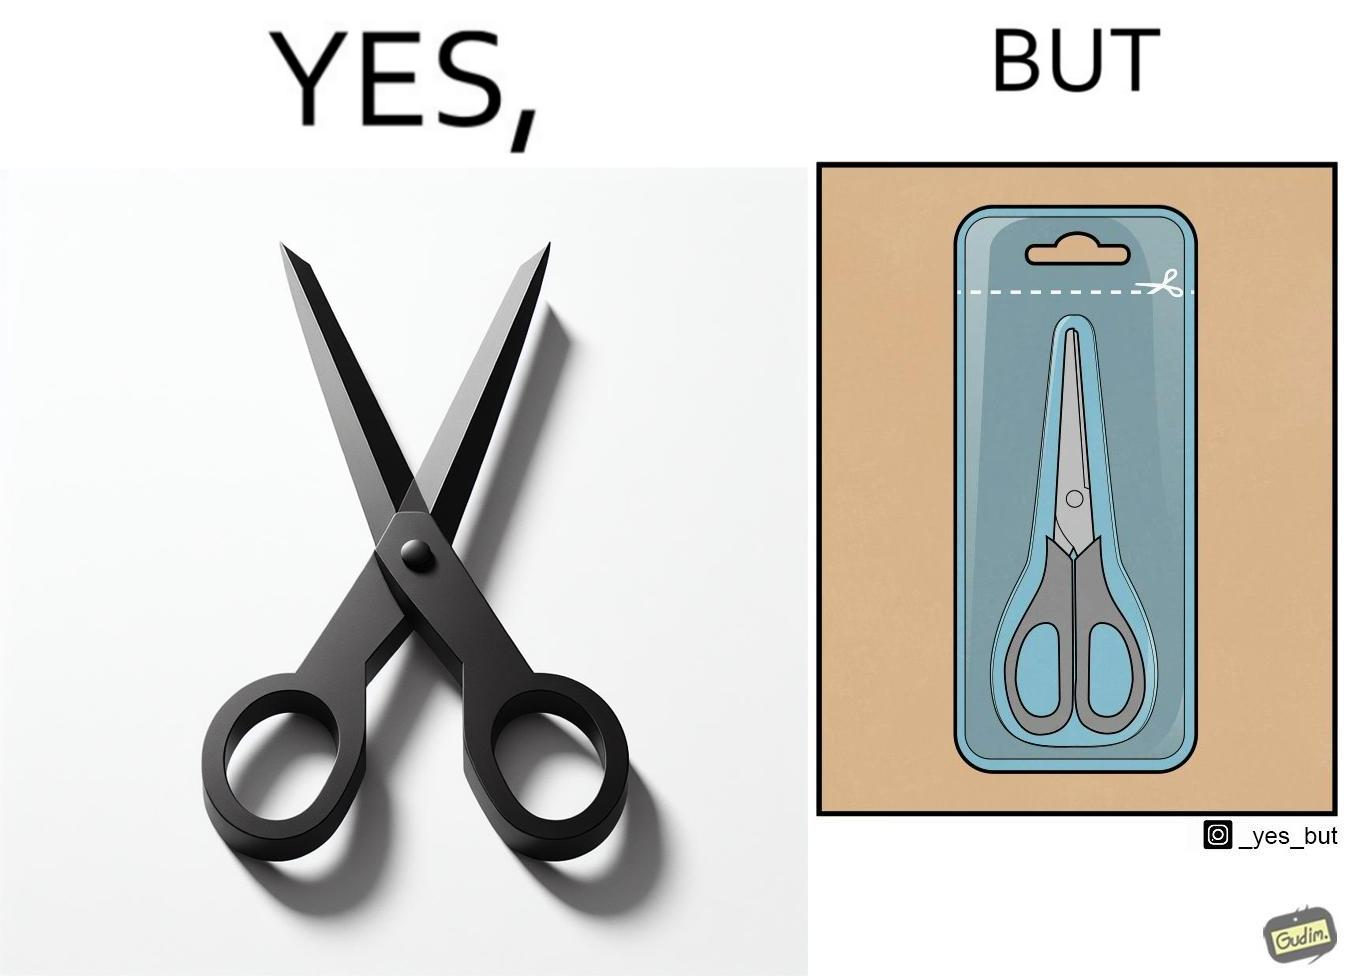Why is this image considered satirical? the image is funny, as the marking at the top of the packaging shows that you would need a pair of scissors to in-turn cut open the pair of scissors that is inside the packaging. 